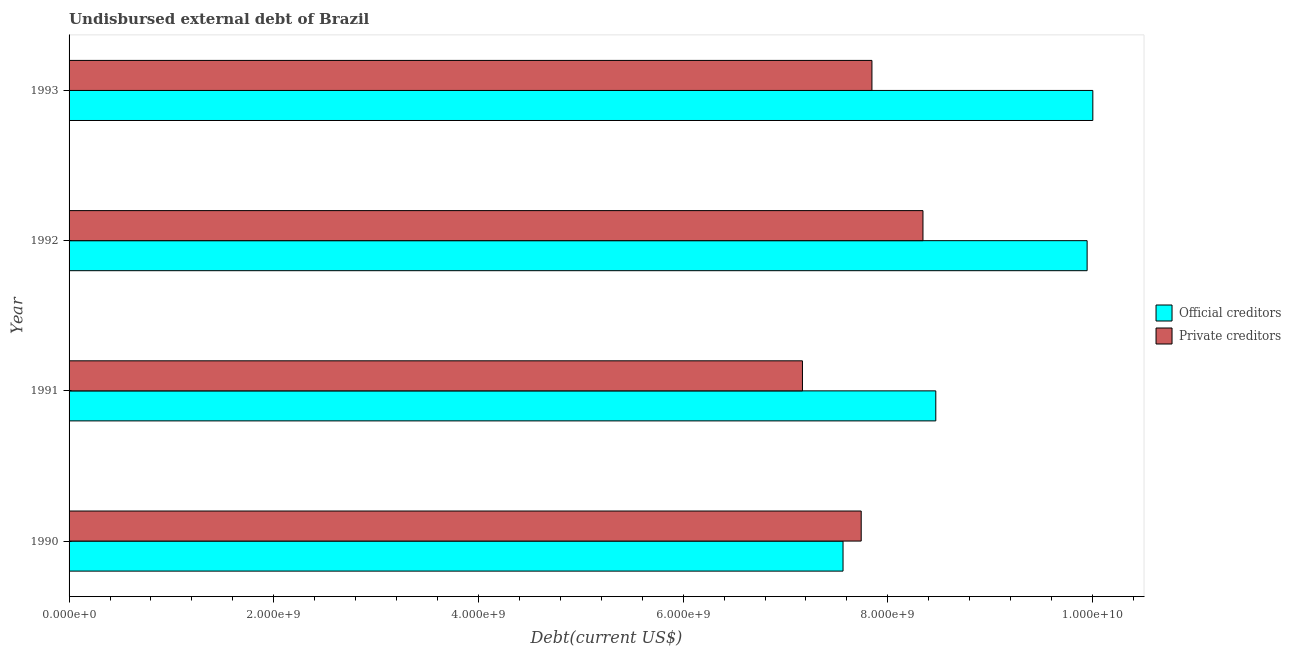How many different coloured bars are there?
Keep it short and to the point. 2. Are the number of bars per tick equal to the number of legend labels?
Your answer should be compact. Yes. What is the label of the 1st group of bars from the top?
Keep it short and to the point. 1993. In how many cases, is the number of bars for a given year not equal to the number of legend labels?
Ensure brevity in your answer.  0. What is the undisbursed external debt of private creditors in 1991?
Offer a very short reply. 7.17e+09. Across all years, what is the maximum undisbursed external debt of private creditors?
Offer a terse response. 8.34e+09. Across all years, what is the minimum undisbursed external debt of official creditors?
Your response must be concise. 7.56e+09. In which year was the undisbursed external debt of private creditors maximum?
Ensure brevity in your answer.  1992. What is the total undisbursed external debt of official creditors in the graph?
Make the answer very short. 3.60e+1. What is the difference between the undisbursed external debt of official creditors in 1990 and that in 1992?
Offer a terse response. -2.38e+09. What is the difference between the undisbursed external debt of private creditors in 1991 and the undisbursed external debt of official creditors in 1993?
Provide a succinct answer. -2.84e+09. What is the average undisbursed external debt of official creditors per year?
Provide a short and direct response. 8.99e+09. In the year 1990, what is the difference between the undisbursed external debt of official creditors and undisbursed external debt of private creditors?
Give a very brief answer. -1.78e+08. What is the ratio of the undisbursed external debt of official creditors in 1991 to that in 1992?
Provide a short and direct response. 0.85. Is the difference between the undisbursed external debt of official creditors in 1990 and 1991 greater than the difference between the undisbursed external debt of private creditors in 1990 and 1991?
Keep it short and to the point. No. What is the difference between the highest and the second highest undisbursed external debt of private creditors?
Offer a terse response. 4.99e+08. What is the difference between the highest and the lowest undisbursed external debt of private creditors?
Offer a terse response. 1.18e+09. In how many years, is the undisbursed external debt of official creditors greater than the average undisbursed external debt of official creditors taken over all years?
Your response must be concise. 2. Is the sum of the undisbursed external debt of private creditors in 1990 and 1992 greater than the maximum undisbursed external debt of official creditors across all years?
Offer a terse response. Yes. What does the 2nd bar from the top in 1990 represents?
Keep it short and to the point. Official creditors. What does the 2nd bar from the bottom in 1992 represents?
Ensure brevity in your answer.  Private creditors. How many bars are there?
Provide a short and direct response. 8. Are all the bars in the graph horizontal?
Make the answer very short. Yes. How many years are there in the graph?
Your answer should be very brief. 4. Are the values on the major ticks of X-axis written in scientific E-notation?
Your response must be concise. Yes. Does the graph contain any zero values?
Give a very brief answer. No. Does the graph contain grids?
Your answer should be compact. No. Where does the legend appear in the graph?
Your response must be concise. Center right. What is the title of the graph?
Ensure brevity in your answer.  Undisbursed external debt of Brazil. Does "Arms imports" appear as one of the legend labels in the graph?
Provide a succinct answer. No. What is the label or title of the X-axis?
Offer a very short reply. Debt(current US$). What is the label or title of the Y-axis?
Provide a short and direct response. Year. What is the Debt(current US$) in Official creditors in 1990?
Ensure brevity in your answer.  7.56e+09. What is the Debt(current US$) of Private creditors in 1990?
Provide a succinct answer. 7.74e+09. What is the Debt(current US$) of Official creditors in 1991?
Keep it short and to the point. 8.47e+09. What is the Debt(current US$) of Private creditors in 1991?
Your response must be concise. 7.17e+09. What is the Debt(current US$) in Official creditors in 1992?
Your answer should be compact. 9.95e+09. What is the Debt(current US$) in Private creditors in 1992?
Offer a very short reply. 8.34e+09. What is the Debt(current US$) in Official creditors in 1993?
Your response must be concise. 1.00e+1. What is the Debt(current US$) of Private creditors in 1993?
Ensure brevity in your answer.  7.84e+09. Across all years, what is the maximum Debt(current US$) of Official creditors?
Your response must be concise. 1.00e+1. Across all years, what is the maximum Debt(current US$) in Private creditors?
Keep it short and to the point. 8.34e+09. Across all years, what is the minimum Debt(current US$) of Official creditors?
Offer a terse response. 7.56e+09. Across all years, what is the minimum Debt(current US$) of Private creditors?
Offer a terse response. 7.17e+09. What is the total Debt(current US$) in Official creditors in the graph?
Give a very brief answer. 3.60e+1. What is the total Debt(current US$) in Private creditors in the graph?
Provide a succinct answer. 3.11e+1. What is the difference between the Debt(current US$) in Official creditors in 1990 and that in 1991?
Your response must be concise. -9.06e+08. What is the difference between the Debt(current US$) in Private creditors in 1990 and that in 1991?
Your answer should be compact. 5.74e+08. What is the difference between the Debt(current US$) in Official creditors in 1990 and that in 1992?
Your answer should be very brief. -2.38e+09. What is the difference between the Debt(current US$) of Private creditors in 1990 and that in 1992?
Provide a succinct answer. -6.03e+08. What is the difference between the Debt(current US$) in Official creditors in 1990 and that in 1993?
Your answer should be compact. -2.44e+09. What is the difference between the Debt(current US$) in Private creditors in 1990 and that in 1993?
Give a very brief answer. -1.05e+08. What is the difference between the Debt(current US$) in Official creditors in 1991 and that in 1992?
Your answer should be very brief. -1.48e+09. What is the difference between the Debt(current US$) of Private creditors in 1991 and that in 1992?
Provide a short and direct response. -1.18e+09. What is the difference between the Debt(current US$) in Official creditors in 1991 and that in 1993?
Your response must be concise. -1.53e+09. What is the difference between the Debt(current US$) in Private creditors in 1991 and that in 1993?
Offer a terse response. -6.79e+08. What is the difference between the Debt(current US$) of Official creditors in 1992 and that in 1993?
Keep it short and to the point. -5.58e+07. What is the difference between the Debt(current US$) in Private creditors in 1992 and that in 1993?
Provide a short and direct response. 4.99e+08. What is the difference between the Debt(current US$) of Official creditors in 1990 and the Debt(current US$) of Private creditors in 1991?
Give a very brief answer. 3.97e+08. What is the difference between the Debt(current US$) of Official creditors in 1990 and the Debt(current US$) of Private creditors in 1992?
Offer a terse response. -7.81e+08. What is the difference between the Debt(current US$) in Official creditors in 1990 and the Debt(current US$) in Private creditors in 1993?
Make the answer very short. -2.82e+08. What is the difference between the Debt(current US$) in Official creditors in 1991 and the Debt(current US$) in Private creditors in 1992?
Offer a terse response. 1.25e+08. What is the difference between the Debt(current US$) in Official creditors in 1991 and the Debt(current US$) in Private creditors in 1993?
Give a very brief answer. 6.24e+08. What is the difference between the Debt(current US$) in Official creditors in 1992 and the Debt(current US$) in Private creditors in 1993?
Your response must be concise. 2.10e+09. What is the average Debt(current US$) in Official creditors per year?
Your answer should be compact. 8.99e+09. What is the average Debt(current US$) in Private creditors per year?
Offer a very short reply. 7.77e+09. In the year 1990, what is the difference between the Debt(current US$) in Official creditors and Debt(current US$) in Private creditors?
Offer a terse response. -1.78e+08. In the year 1991, what is the difference between the Debt(current US$) of Official creditors and Debt(current US$) of Private creditors?
Your answer should be very brief. 1.30e+09. In the year 1992, what is the difference between the Debt(current US$) of Official creditors and Debt(current US$) of Private creditors?
Your response must be concise. 1.60e+09. In the year 1993, what is the difference between the Debt(current US$) in Official creditors and Debt(current US$) in Private creditors?
Provide a short and direct response. 2.16e+09. What is the ratio of the Debt(current US$) in Official creditors in 1990 to that in 1991?
Keep it short and to the point. 0.89. What is the ratio of the Debt(current US$) of Private creditors in 1990 to that in 1991?
Make the answer very short. 1.08. What is the ratio of the Debt(current US$) in Official creditors in 1990 to that in 1992?
Your response must be concise. 0.76. What is the ratio of the Debt(current US$) of Private creditors in 1990 to that in 1992?
Give a very brief answer. 0.93. What is the ratio of the Debt(current US$) in Official creditors in 1990 to that in 1993?
Offer a very short reply. 0.76. What is the ratio of the Debt(current US$) of Private creditors in 1990 to that in 1993?
Your response must be concise. 0.99. What is the ratio of the Debt(current US$) in Official creditors in 1991 to that in 1992?
Ensure brevity in your answer.  0.85. What is the ratio of the Debt(current US$) of Private creditors in 1991 to that in 1992?
Ensure brevity in your answer.  0.86. What is the ratio of the Debt(current US$) in Official creditors in 1991 to that in 1993?
Your response must be concise. 0.85. What is the ratio of the Debt(current US$) of Private creditors in 1991 to that in 1993?
Offer a terse response. 0.91. What is the ratio of the Debt(current US$) of Private creditors in 1992 to that in 1993?
Offer a terse response. 1.06. What is the difference between the highest and the second highest Debt(current US$) in Official creditors?
Offer a very short reply. 5.58e+07. What is the difference between the highest and the second highest Debt(current US$) of Private creditors?
Ensure brevity in your answer.  4.99e+08. What is the difference between the highest and the lowest Debt(current US$) of Official creditors?
Provide a short and direct response. 2.44e+09. What is the difference between the highest and the lowest Debt(current US$) in Private creditors?
Provide a short and direct response. 1.18e+09. 